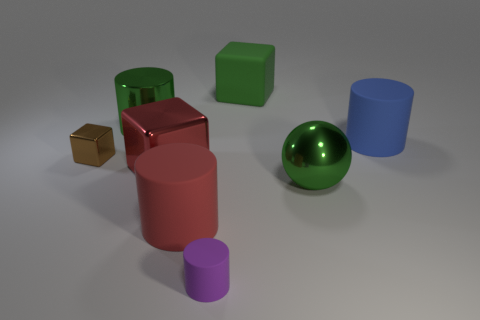Subtract all big metallic cylinders. How many cylinders are left? 3 Add 1 large metallic things. How many objects exist? 9 Subtract 2 cubes. How many cubes are left? 1 Subtract all green cylinders. How many cylinders are left? 3 Add 6 big green spheres. How many big green spheres exist? 7 Subtract 0 red balls. How many objects are left? 8 Subtract all spheres. How many objects are left? 7 Subtract all cyan balls. Subtract all blue cylinders. How many balls are left? 1 Subtract all small green spheres. Subtract all large matte cubes. How many objects are left? 7 Add 2 small things. How many small things are left? 4 